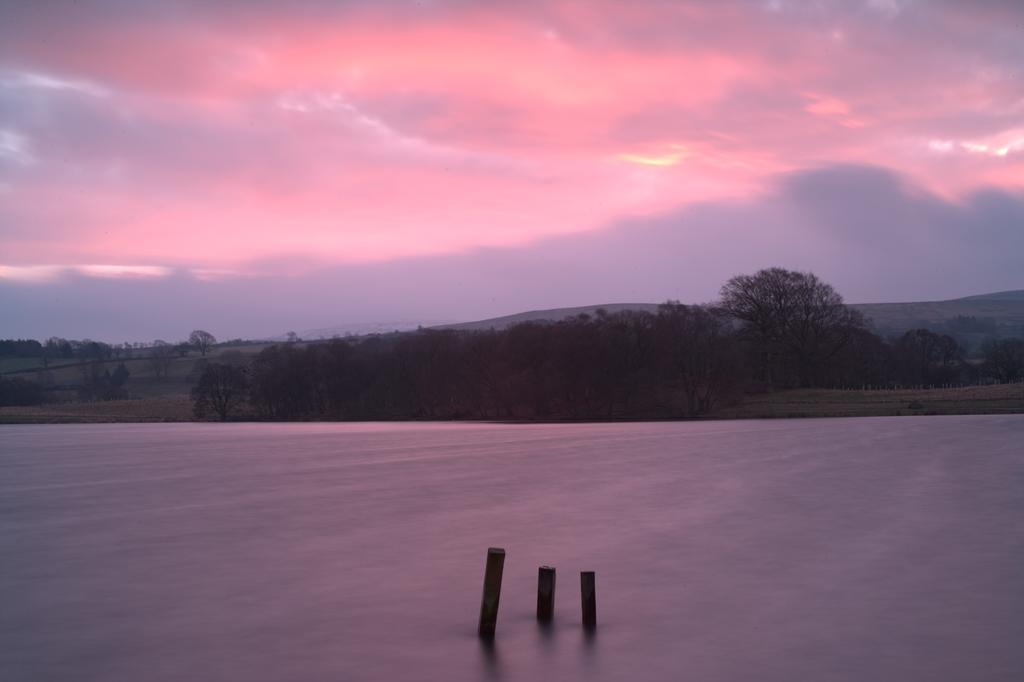What is the primary element in the image? There is water in the image. What structures can be seen in the water? There are three poles in the water. What can be seen in the background of the image? There are trees and hills in the background of the image. What is the color of the sky in the image? The sky is visible in the background of the image, with red and gray colors. What type of plantation can be seen in the image? There is no plantation present in the image; it features water, poles, trees, hills, and a red and gray sky. What creature is swimming in the water in the image? There is no creature visible in the water in the image; it only contains poles. 